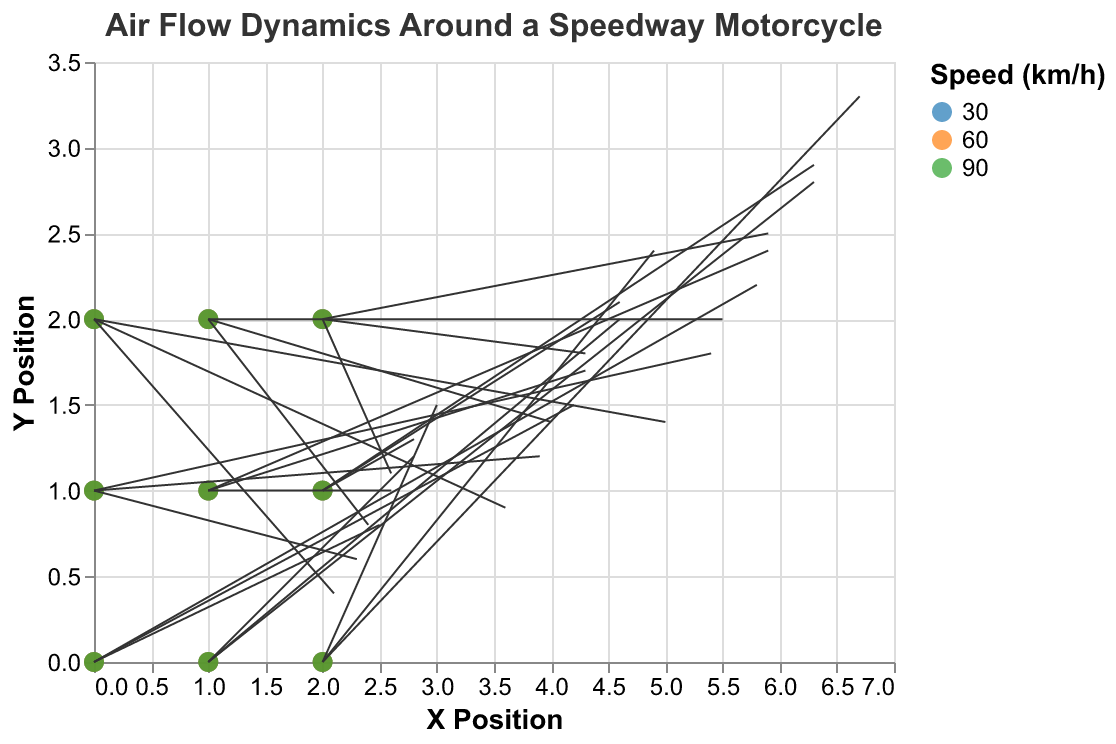What is the title of the plot? The title of the plot is mentioned in the "title" section of the code and is displayed at the top of the figure.
Answer: Air Flow Dynamics Around a Speedway Motorcycle How many different speeds are represented in the plot? The data has three distinct speed values, which are indicated in the "color" legend of the figure.
Answer: 3 What color represents the speed of 60 km/h? The legend indicates that the speed of 60 km/h is associated with the color orange.
Answer: Orange Which data point (x, y) at speed 30 km/h has the highest U component? To find this, look at the data points where the "speed" is 30. Of these, the point with the highest U component is at x = 2, y = 0 with u = 3.0.
Answer: (2, 0) Which (x, y) position has the highest U component at speed 90 km/h? Analyzing the data points where the "speed" is 90, the highest U component (u = 6.7) is at x = 2, y = 0.
Answer: (2, 0) At speed 60 km/h, which (x, y) position has the smallest V component? For speed 60 km/h, the smallest V component (v = 0.9) is at x = 0, y = 2.
Answer: (0, 2) What is the X Position value where the U component at speed 90 km/h is 5.0? When examining the data for speed 90, the U component of 5.0 occurs at (x = 0, y = 2).
Answer: 0 How does the U component at (x = 2, y = 1) change as the speed increases from 30 km/h to 90 km/h? The U component at (x = 2, y = 1) for speeds 30, 60, and 90 km/h are 2.8, 4.6, and 6.3 respectively, showing an increase as speed increases.
Answer: Increases What is the average V component at (x = 1, y = 1) across all speeds? At (x = 1, y = 1), the V components are 1.0 (30 km/h), 1.7 (60 km/h), and 2.4 (90 km/h). The average is (1.0 + 1.7 + 2.4) / 3 = 1.7.
Answer: 1.7 